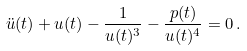<formula> <loc_0><loc_0><loc_500><loc_500>\ddot { u } ( t ) + u ( t ) - \frac { 1 } { u ( t ) ^ { 3 } } - \frac { p ( t ) } { u ( t ) ^ { 4 } } = 0 \, .</formula> 